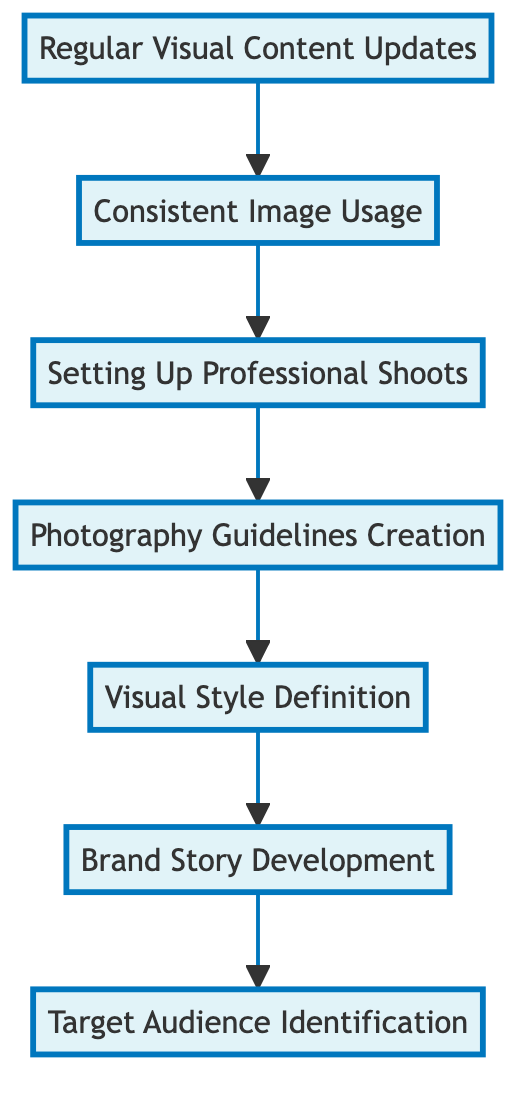What is the last step in the flow chart? The flow chart indicates that the last step, or the topmost element, is "Target Audience Identification". It is the final node in the flow indicating where the process converges.
Answer: Target Audience Identification How many total elements are present in the flow chart? By counting all the individual nodes in the diagram, we can see that there are seven elements present in total: Regular Visual Content Updates, Consistent Image Usage, Setting Up Professional Shoots, Photography Guidelines Creation, Visual Style Definition, Brand Story Development, and Target Audience Identification.
Answer: 7 Which element comes directly before "Setting Up Professional Shoots"? To find the predecessor of "Setting Up Professional Shoots", we move upward in the flow chart, and we see that "Consistent Image Usage" is directly below it, making it the predecessor in this flow.
Answer: Consistent Image Usage What is the sequence of elements starting from "Regular Visual Content Updates"? The flow can be traced starting from "Regular Visual Content Updates" moving upward through the subsequent nodes: Regular Visual Content Updates leads to Consistent Image Usage, then to Setting Up Professional Shoots, followed by Photography Guidelines Creation, then to Visual Style Definition, next is Brand Story Development, and finally reaching Target Audience Identification.
Answer: Consistent Image Usage, Setting Up Professional Shoots, Photography Guidelines Creation, Visual Style Definition, Brand Story Development, Target Audience Identification Which node serves as a foundation for defining the brand's visual style? The foundational node for defining the brand's visual style is "Visual Style Definition," as it relies on the information derived from the prior step which is "Brand Story Development" to ensure alignment with the brand narrative.
Answer: Visual Style Definition What does moving from "Setting Up Professional Shoots" to "Photography Guidelines Creation" represent in this flow? Moving from "Setting Up Professional Shoots" to "Photography Guidelines Creation" represents a transition from the action of organizing shoots to creating specific rules and standards for how those shoots should visually represent the brand, ensuring a cohesive visual output.
Answer: Transition to guidelines creation How does "Target Audience Identification" relate to the rest of the flow chart? "Target Audience Identification" serves as the ultimate goal of the flow chart, as it encompasses understanding who the visual identity is designed for, informing all preceding steps including branding and visual stylization, thus ensuring the created content is relevant and effective.
Answer: Ultimate goal of the flow chart 